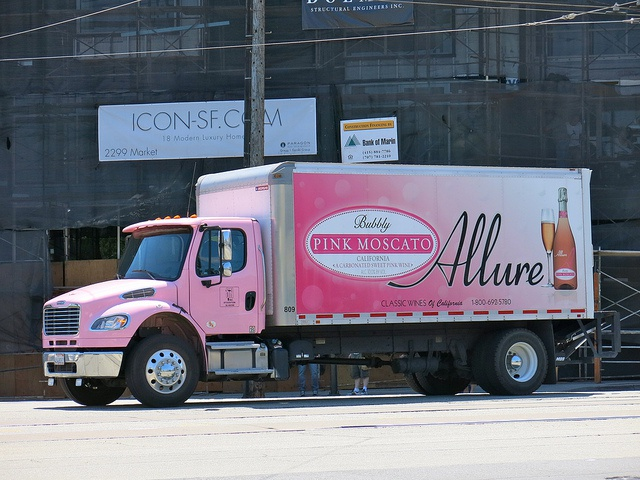Describe the objects in this image and their specific colors. I can see truck in black, darkgray, and violet tones, bottle in black, brown, darkgray, and violet tones, people in black and darkblue tones, wine glass in black, tan, darkgray, and brown tones, and people in black, gray, and blue tones in this image. 